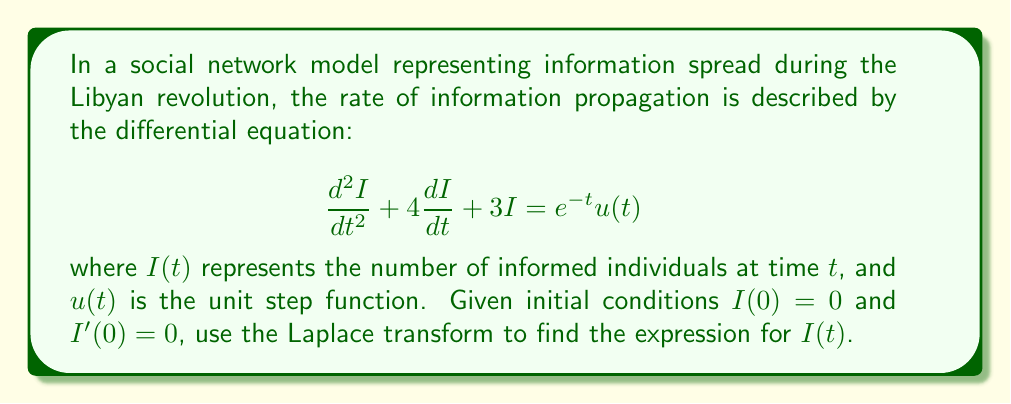Can you solve this math problem? Let's solve this problem step by step using the Laplace transform:

1) First, we take the Laplace transform of both sides of the equation:
   $$\mathcal{L}\{d^2I/dt^2 + 4dI/dt + 3I\} = \mathcal{L}\{e^{-t}u(t)\}$$

2) Using Laplace transform properties:
   $$s^2I(s) - sI(0) - I'(0) + 4[sI(s) - I(0)] + 3I(s) = \frac{1}{s+1}$$

3) Substituting the initial conditions $I(0) = 0$ and $I'(0) = 0$:
   $$s^2I(s) + 4sI(s) + 3I(s) = \frac{1}{s+1}$$

4) Factoring out $I(s)$:
   $$I(s)(s^2 + 4s + 3) = \frac{1}{s+1}$$

5) Solving for $I(s)$:
   $$I(s) = \frac{1}{(s+1)(s^2 + 4s + 3)}$$

6) Using partial fraction decomposition:
   $$I(s) = \frac{A}{s+1} + \frac{Bs+C}{s^2 + 4s + 3}$$

7) Finding $A$, $B$, and $C$:
   $$A = -\frac{1}{6}, B = \frac{1}{6}, C = -\frac{1}{3}$$

8) Rewriting $I(s)$:
   $$I(s) = -\frac{1}{6(s+1)} + \frac{1}{6}\cdot\frac{s+2}{(s+1)(s+3)}$$

9) Taking the inverse Laplace transform:
   $$I(t) = -\frac{1}{6}e^{-t} + \frac{1}{6}(e^{-t} - e^{-3t})$$

10) Simplifying:
    $$I(t) = \frac{1}{6}(e^{-t} - e^{-3t})$$
Answer: $I(t) = \frac{1}{6}(e^{-t} - e^{-3t})$ 